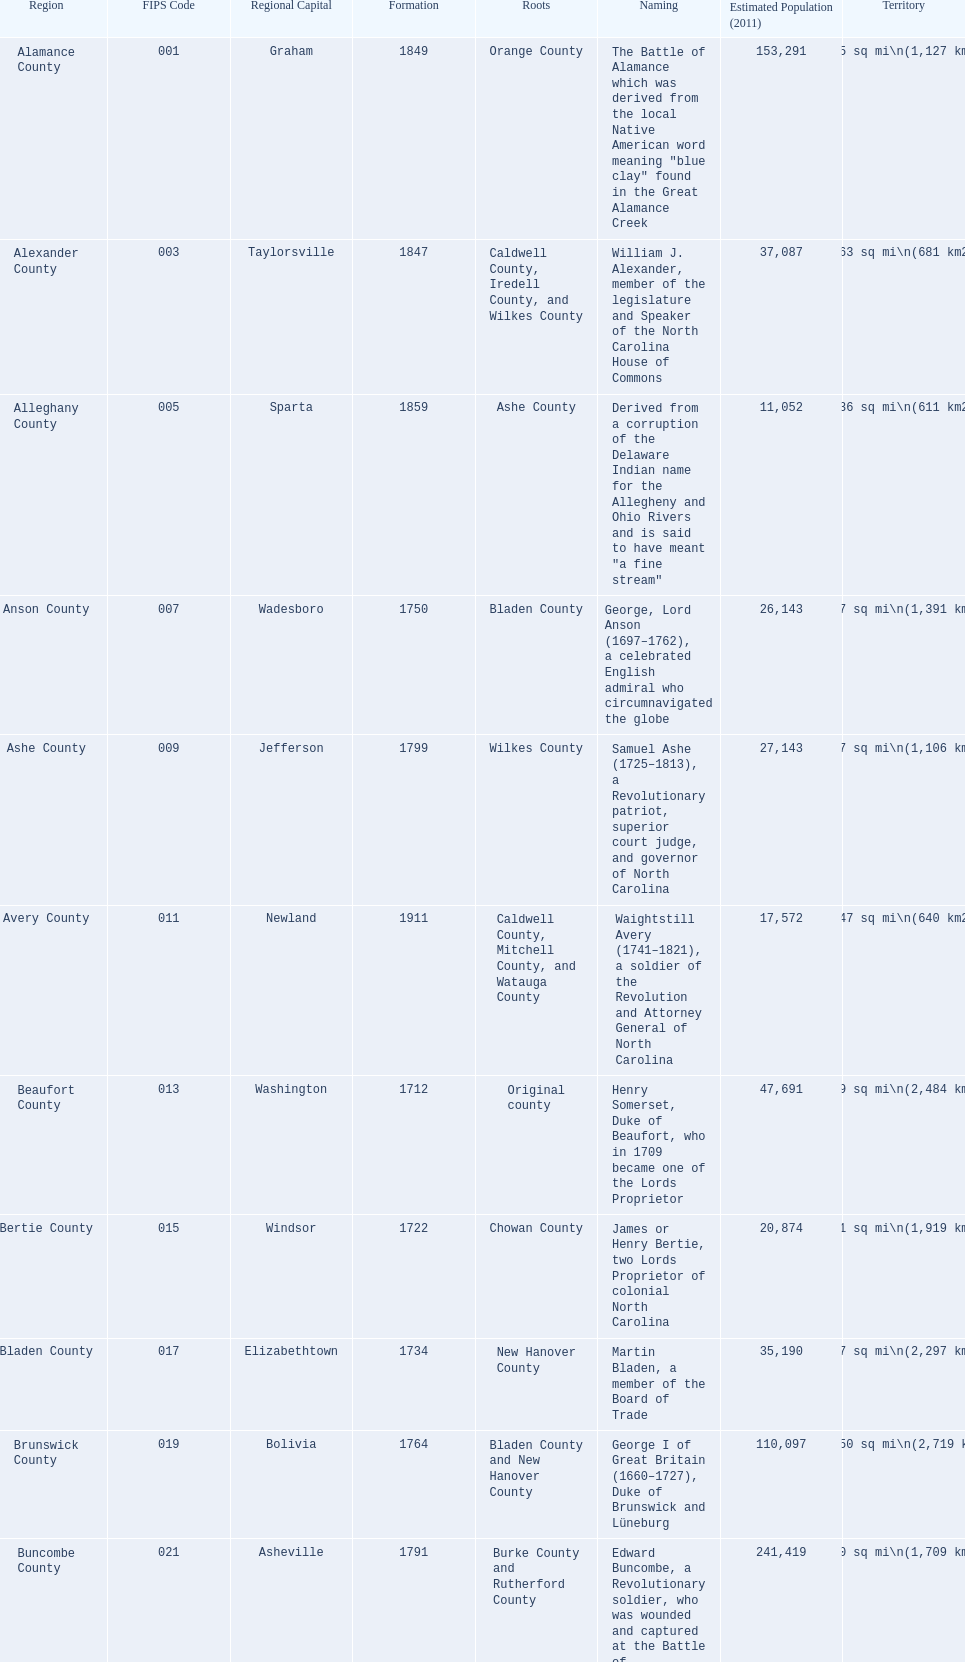Apart from mecklenburg, which county possesses the biggest population? Wake County. 